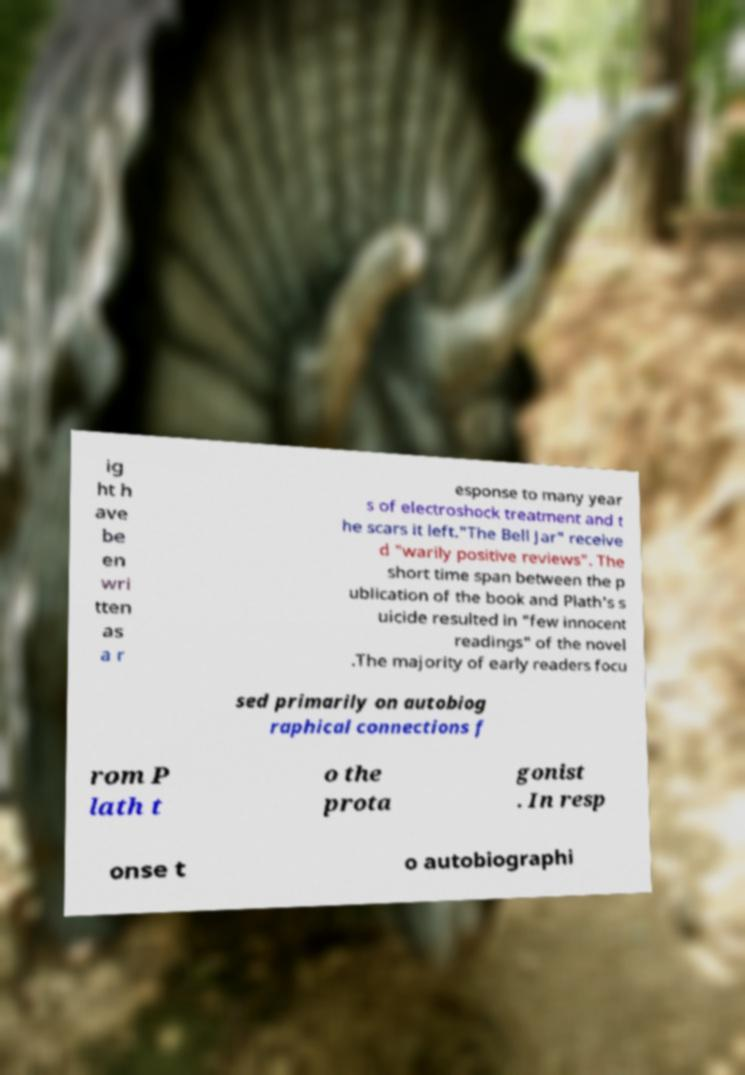Can you read and provide the text displayed in the image?This photo seems to have some interesting text. Can you extract and type it out for me? ig ht h ave be en wri tten as a r esponse to many year s of electroshock treatment and t he scars it left."The Bell Jar" receive d "warily positive reviews". The short time span between the p ublication of the book and Plath's s uicide resulted in "few innocent readings" of the novel .The majority of early readers focu sed primarily on autobiog raphical connections f rom P lath t o the prota gonist . In resp onse t o autobiographi 